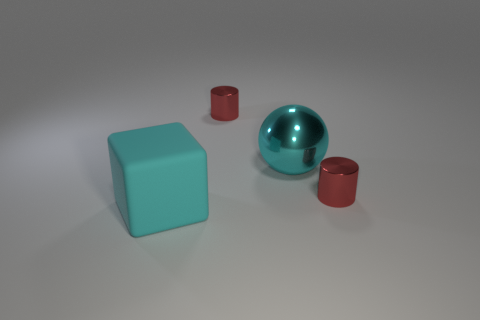How many other big objects have the same shape as the cyan metallic object?
Provide a succinct answer. 0. What number of big cyan shiny things are there?
Your answer should be very brief. 1. There is a thing that is behind the large matte cube and left of the shiny sphere; what is its size?
Your answer should be compact. Small. What shape is the cyan thing that is the same size as the cube?
Ensure brevity in your answer.  Sphere. Is there a red object behind the tiny red metallic cylinder that is to the left of the large sphere?
Provide a succinct answer. No. There is a tiny cylinder right of the cyan shiny object; is it the same color as the large shiny sphere?
Keep it short and to the point. No. How many objects are either objects left of the big cyan shiny sphere or big green rubber balls?
Provide a short and direct response. 2. The big thing that is to the right of the large cube that is in front of the cyan thing that is on the right side of the rubber cube is made of what material?
Your answer should be very brief. Metal. Is the number of large cubes on the right side of the cyan cube greater than the number of red metallic cylinders that are to the right of the ball?
Your answer should be very brief. No. How many balls are matte things or red objects?
Ensure brevity in your answer.  0. 